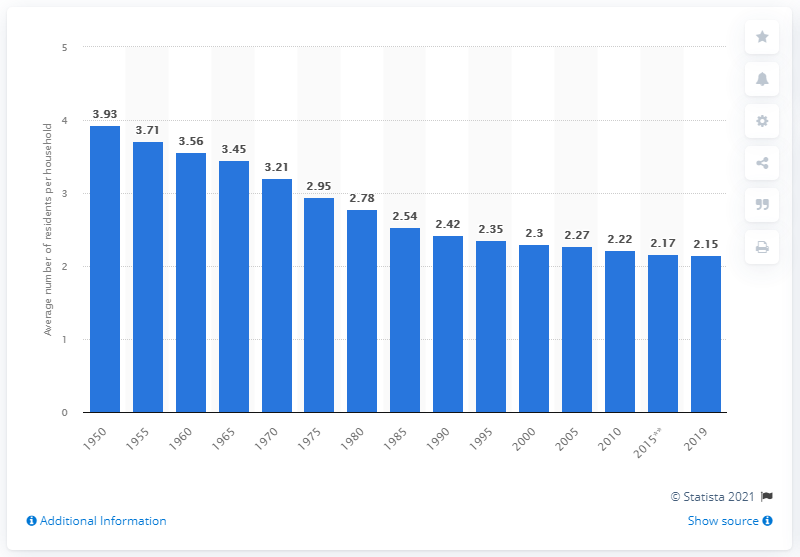Identify some key points in this picture. In the year 1950, the average household size in the Netherlands was 3.93 people. 